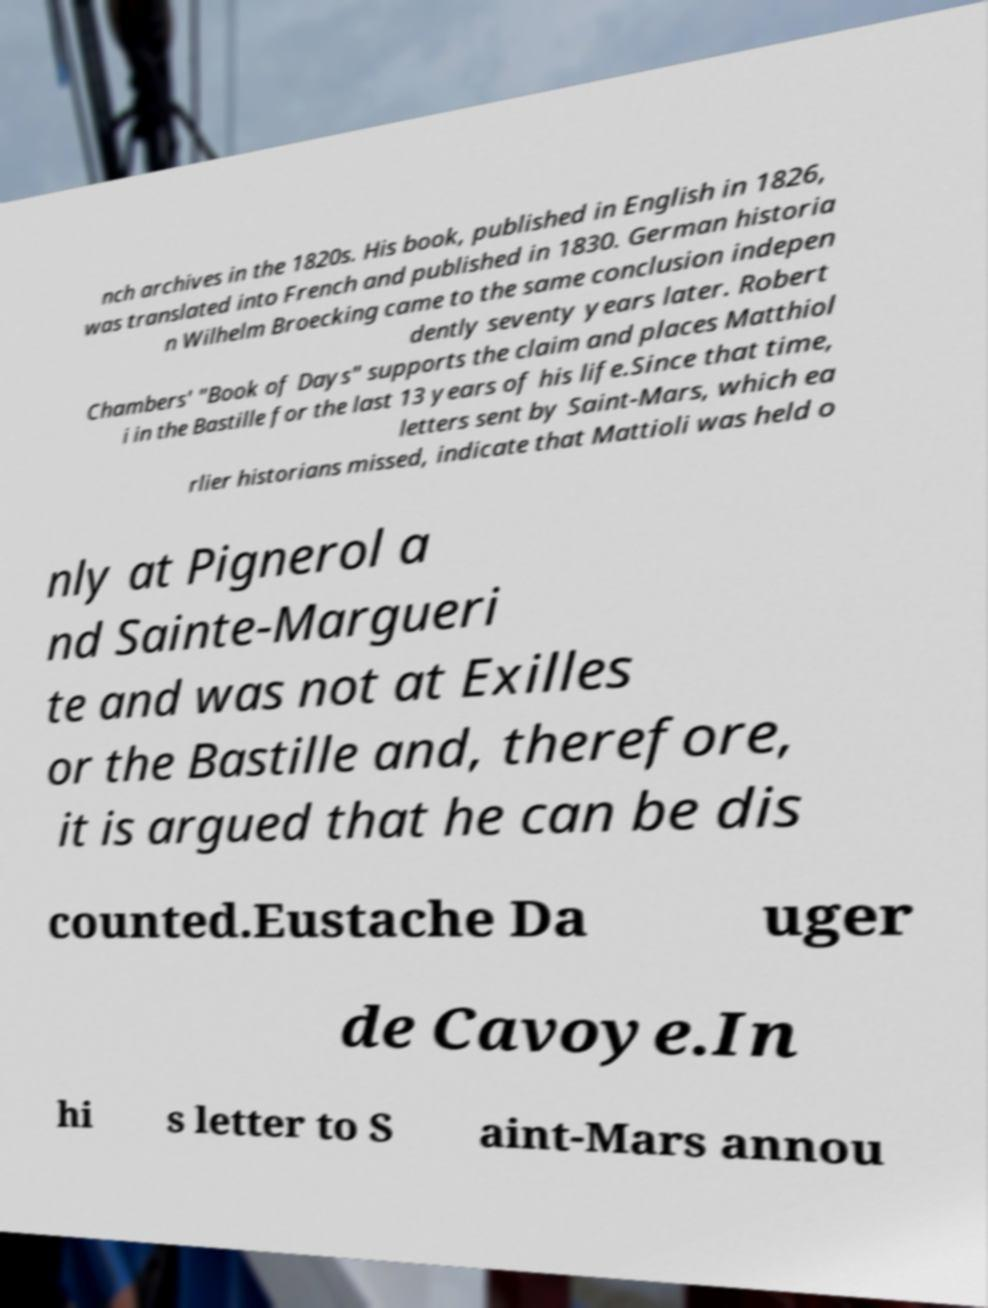Could you extract and type out the text from this image? nch archives in the 1820s. His book, published in English in 1826, was translated into French and published in 1830. German historia n Wilhelm Broecking came to the same conclusion indepen dently seventy years later. Robert Chambers' "Book of Days" supports the claim and places Matthiol i in the Bastille for the last 13 years of his life.Since that time, letters sent by Saint-Mars, which ea rlier historians missed, indicate that Mattioli was held o nly at Pignerol a nd Sainte-Margueri te and was not at Exilles or the Bastille and, therefore, it is argued that he can be dis counted.Eustache Da uger de Cavoye.In hi s letter to S aint-Mars annou 